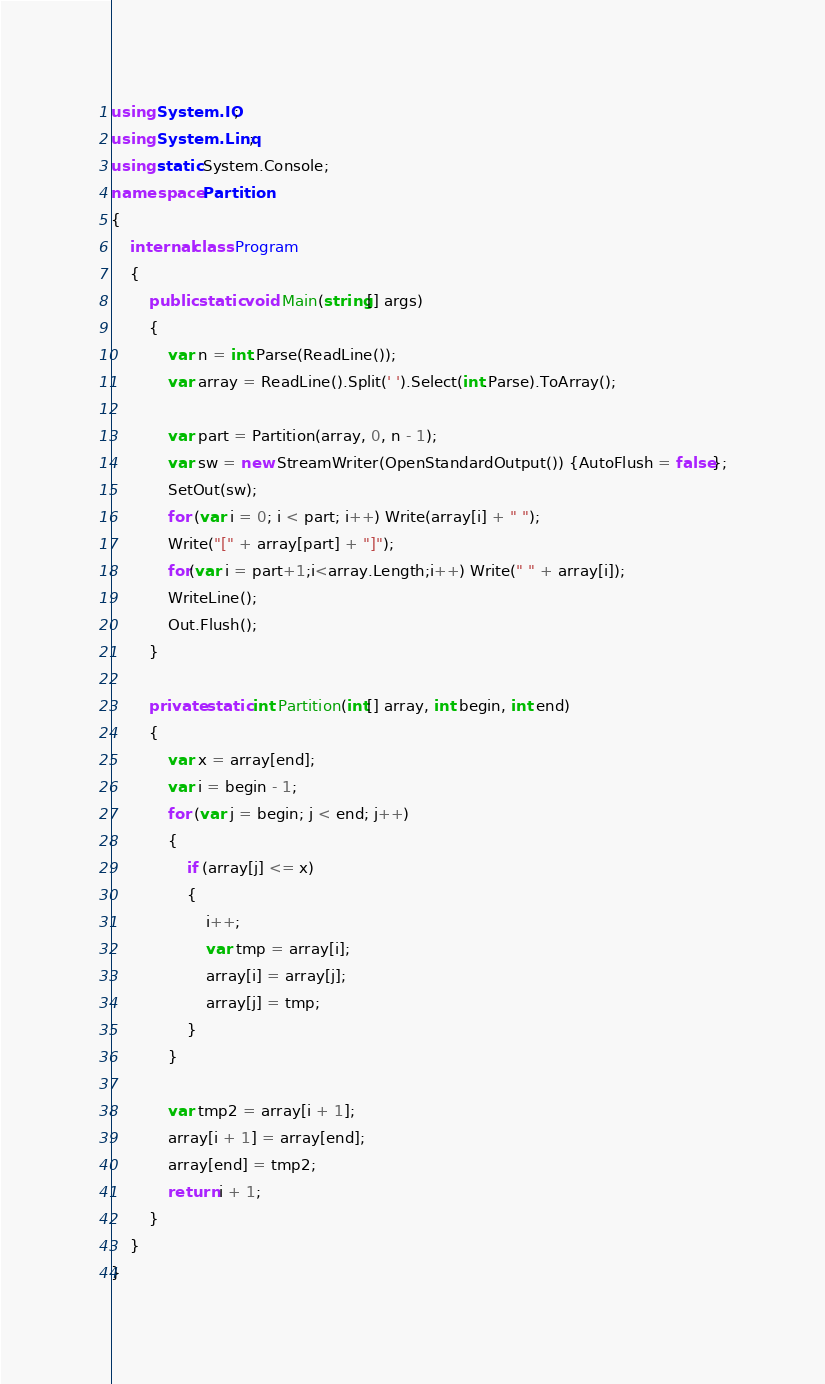<code> <loc_0><loc_0><loc_500><loc_500><_C#_>using System.IO;
using System.Linq;
using static System.Console;
namespace Partition
{
    internal class Program
    {
        public static void Main(string[] args)
        {
            var n = int.Parse(ReadLine());
            var array = ReadLine().Split(' ').Select(int.Parse).ToArray();

            var part = Partition(array, 0, n - 1);
            var sw = new StreamWriter(OpenStandardOutput()) {AutoFlush = false};
            SetOut(sw);
            for (var i = 0; i < part; i++) Write(array[i] + " ");
            Write("[" + array[part] + "]");
            for(var i = part+1;i<array.Length;i++) Write(" " + array[i]);
            WriteLine();
            Out.Flush();
        }

        private static int Partition(int[] array, int begin, int end)
        {
            var x = array[end];
            var i = begin - 1;
            for (var j = begin; j < end; j++)
            {
                if (array[j] <= x)
                {
                    i++;
                    var tmp = array[i];
                    array[i] = array[j];
                    array[j] = tmp;
                }
            }

            var tmp2 = array[i + 1];
            array[i + 1] = array[end];
            array[end] = tmp2;
            return i + 1;
        }
    }
}
</code> 